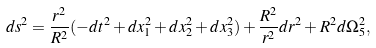Convert formula to latex. <formula><loc_0><loc_0><loc_500><loc_500>d s ^ { 2 } = \frac { r ^ { 2 } } { R ^ { 2 } } ( - d t ^ { 2 } + d x _ { 1 } ^ { 2 } + d x _ { 2 } ^ { 2 } + d x _ { 3 } ^ { 2 } ) + \frac { R ^ { 2 } } { r ^ { 2 } } d r ^ { 2 } + R ^ { 2 } d \Omega _ { 5 } ^ { 2 } ,</formula> 